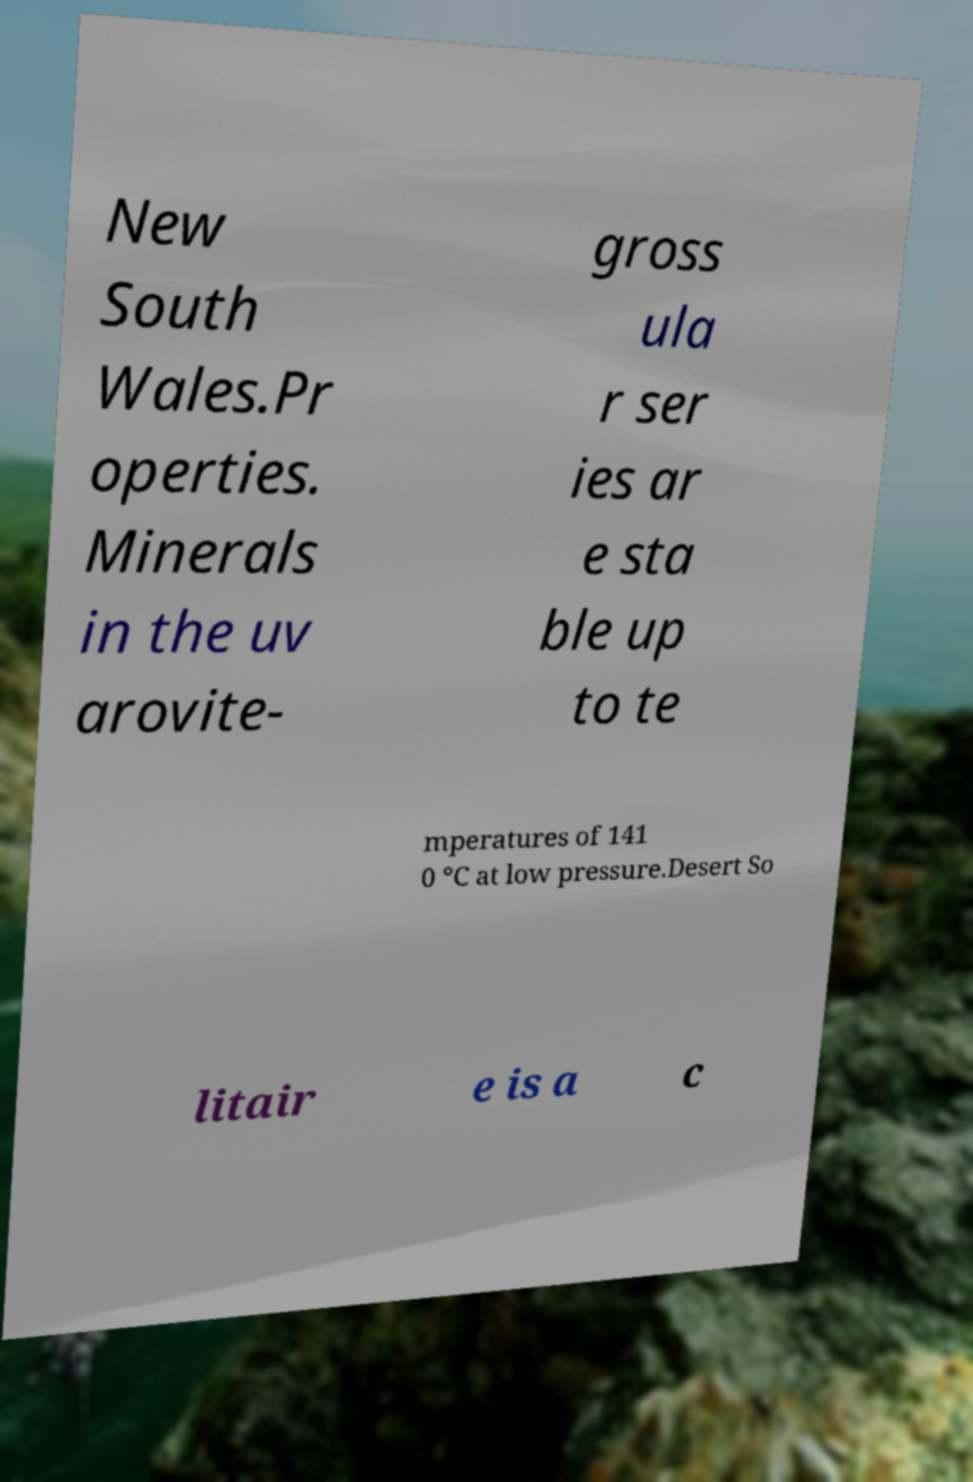Can you read and provide the text displayed in the image?This photo seems to have some interesting text. Can you extract and type it out for me? New South Wales.Pr operties. Minerals in the uv arovite- gross ula r ser ies ar e sta ble up to te mperatures of 141 0 °C at low pressure.Desert So litair e is a c 